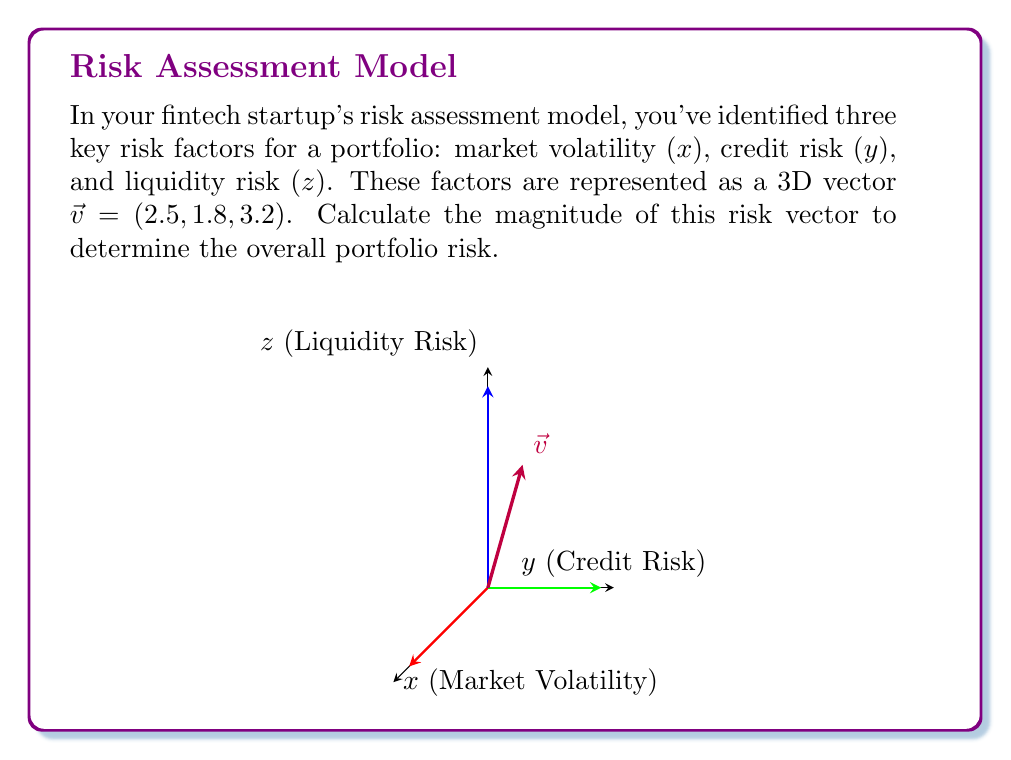Provide a solution to this math problem. To calculate the magnitude of the vector $\vec{v} = (2.5, 1.8, 3.2)$, we use the formula for the magnitude of a 3D vector:

$$\|\vec{v}\| = \sqrt{x^2 + y^2 + z^2}$$

Where $x$, $y$, and $z$ are the components of the vector.

Step 1: Square each component
$x^2 = 2.5^2 = 6.25$
$y^2 = 1.8^2 = 3.24$
$z^2 = 3.2^2 = 10.24$

Step 2: Sum the squared components
$x^2 + y^2 + z^2 = 6.25 + 3.24 + 10.24 = 19.73$

Step 3: Take the square root of the sum
$$\|\vec{v}\| = \sqrt{19.73} \approx 4.44$$

The magnitude of the risk vector is approximately 4.44, representing the overall portfolio risk.
Answer: $4.44$ 